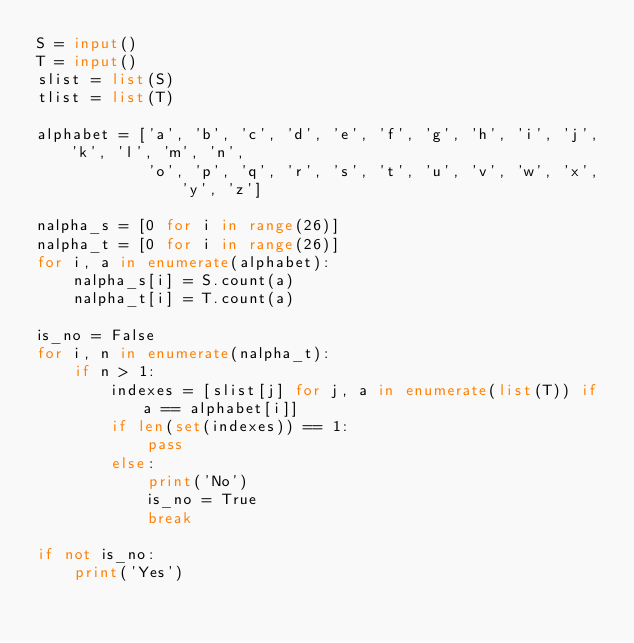Convert code to text. <code><loc_0><loc_0><loc_500><loc_500><_Python_>S = input()
T = input()
slist = list(S)
tlist = list(T)

alphabet = ['a', 'b', 'c', 'd', 'e', 'f', 'g', 'h', 'i', 'j', 'k', 'l', 'm', 'n',
            'o', 'p', 'q', 'r', 's', 't', 'u', 'v', 'w', 'x', 'y', 'z']

nalpha_s = [0 for i in range(26)]
nalpha_t = [0 for i in range(26)]
for i, a in enumerate(alphabet):
    nalpha_s[i] = S.count(a)
    nalpha_t[i] = T.count(a)

is_no = False
for i, n in enumerate(nalpha_t):
    if n > 1:
        indexes = [slist[j] for j, a in enumerate(list(T)) if a == alphabet[i]]
        if len(set(indexes)) == 1:
            pass
        else:
            print('No')
            is_no = True
            break

if not is_no:
    print('Yes')</code> 